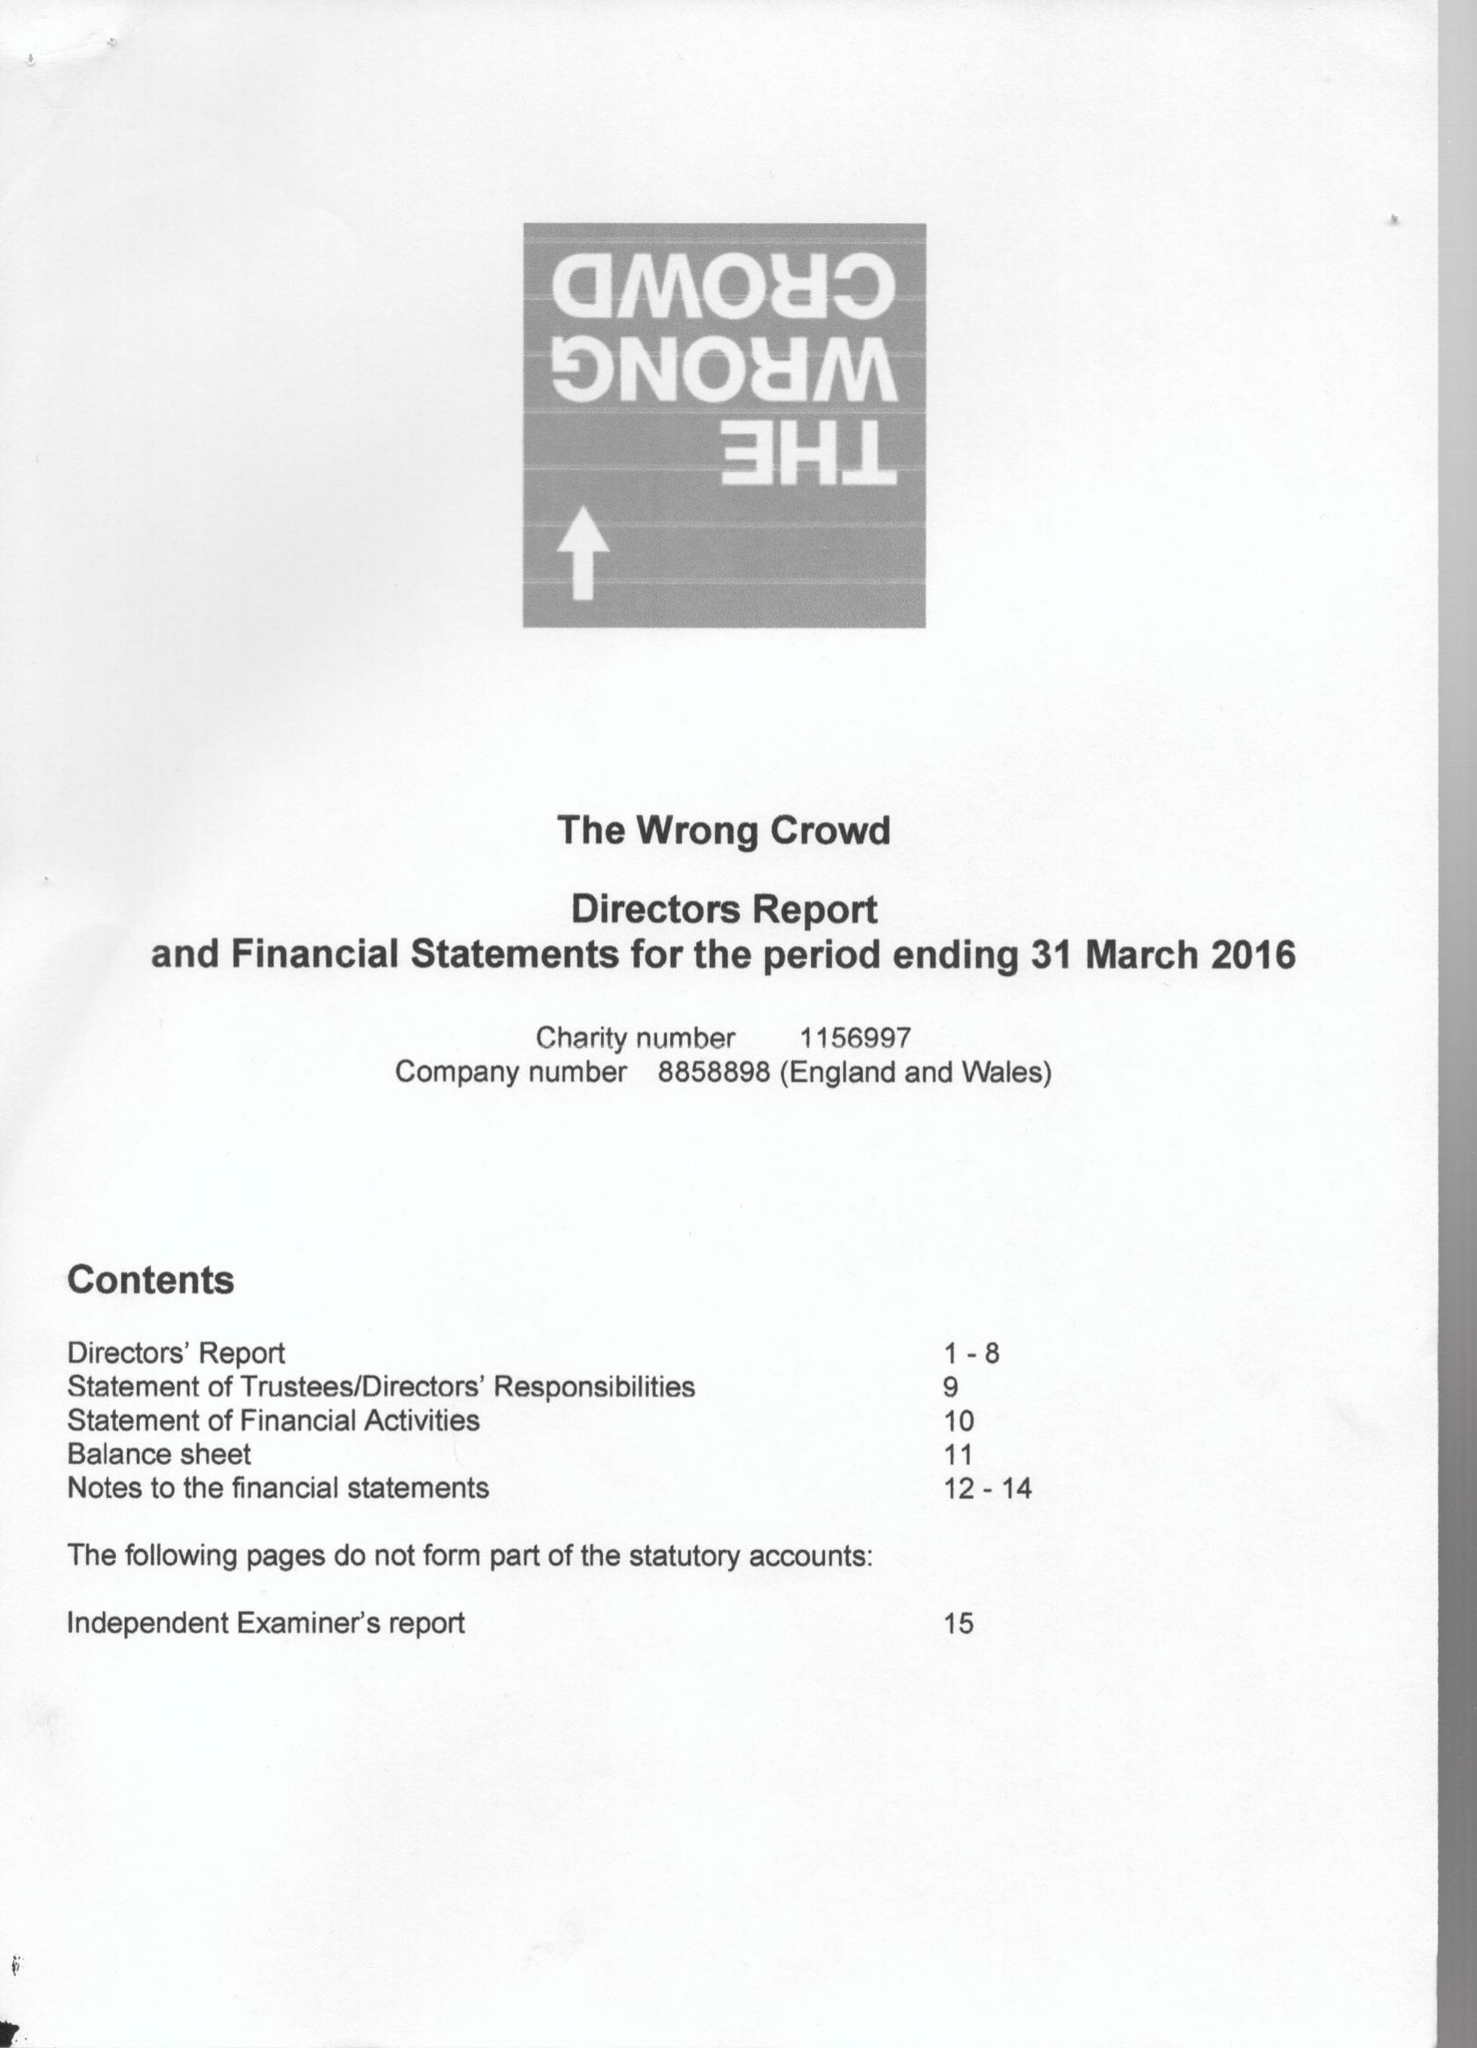What is the value for the report_date?
Answer the question using a single word or phrase. 2016-03-31 